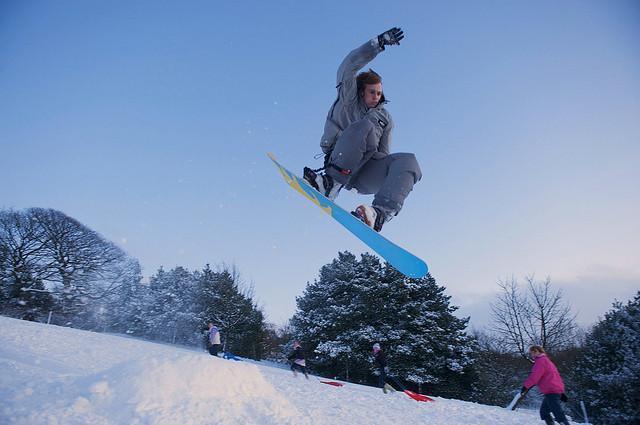How many snowboards are there?
Give a very brief answer. 1. How many horses are there?
Give a very brief answer. 0. 